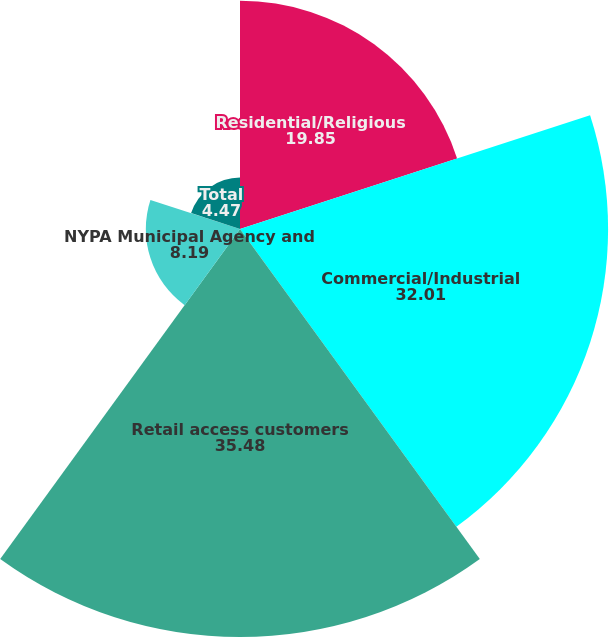Convert chart to OTSL. <chart><loc_0><loc_0><loc_500><loc_500><pie_chart><fcel>Residential/Religious<fcel>Commercial/Industrial<fcel>Retail access customers<fcel>NYPA Municipal Agency and<fcel>Total<nl><fcel>19.85%<fcel>32.01%<fcel>35.48%<fcel>8.19%<fcel>4.47%<nl></chart> 